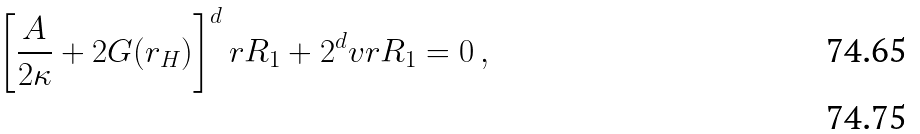Convert formula to latex. <formula><loc_0><loc_0><loc_500><loc_500>\left [ \frac { A } { 2 \kappa } + 2 G ( r _ { H } ) \right ] ^ { d } r R _ { 1 } + 2 ^ { d } v r R _ { 1 } = 0 \, , \\</formula> 